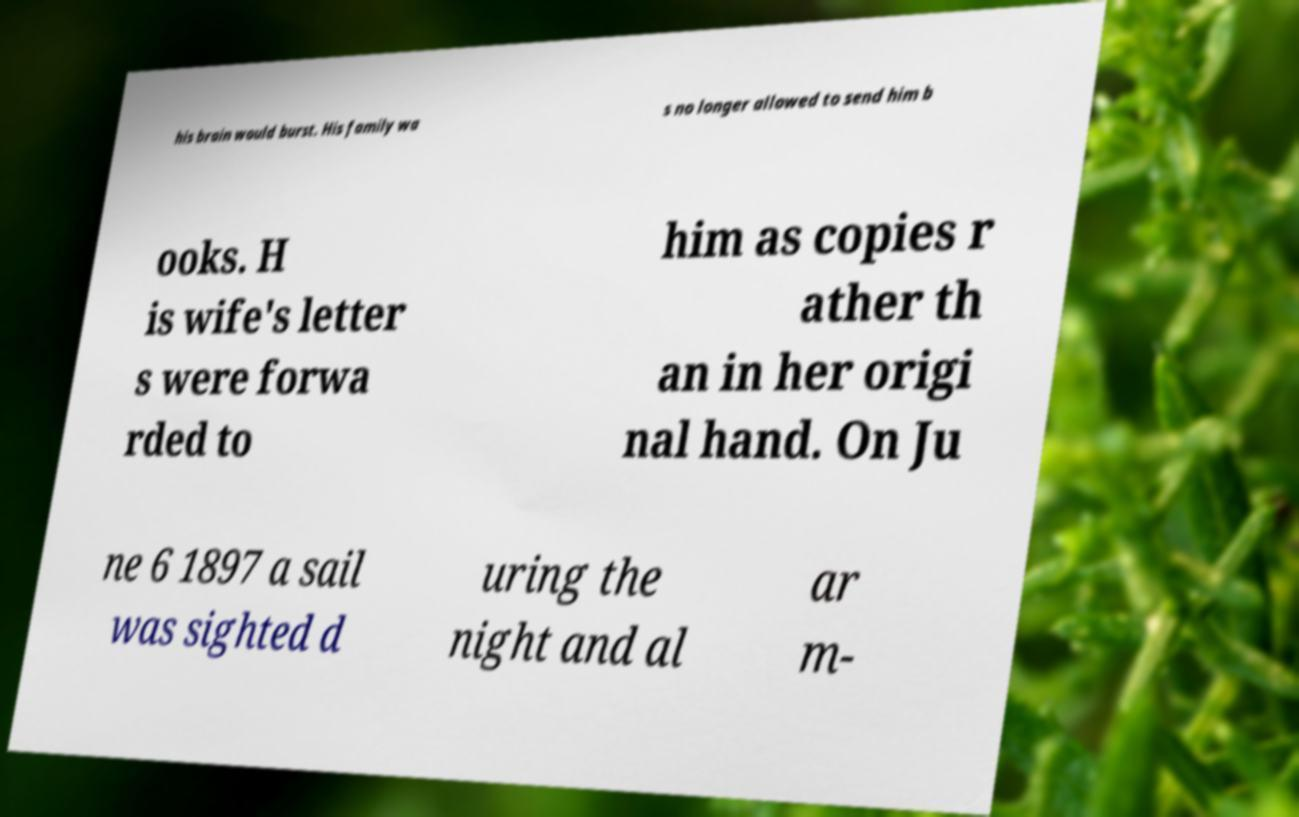Can you read and provide the text displayed in the image?This photo seems to have some interesting text. Can you extract and type it out for me? his brain would burst. His family wa s no longer allowed to send him b ooks. H is wife's letter s were forwa rded to him as copies r ather th an in her origi nal hand. On Ju ne 6 1897 a sail was sighted d uring the night and al ar m- 